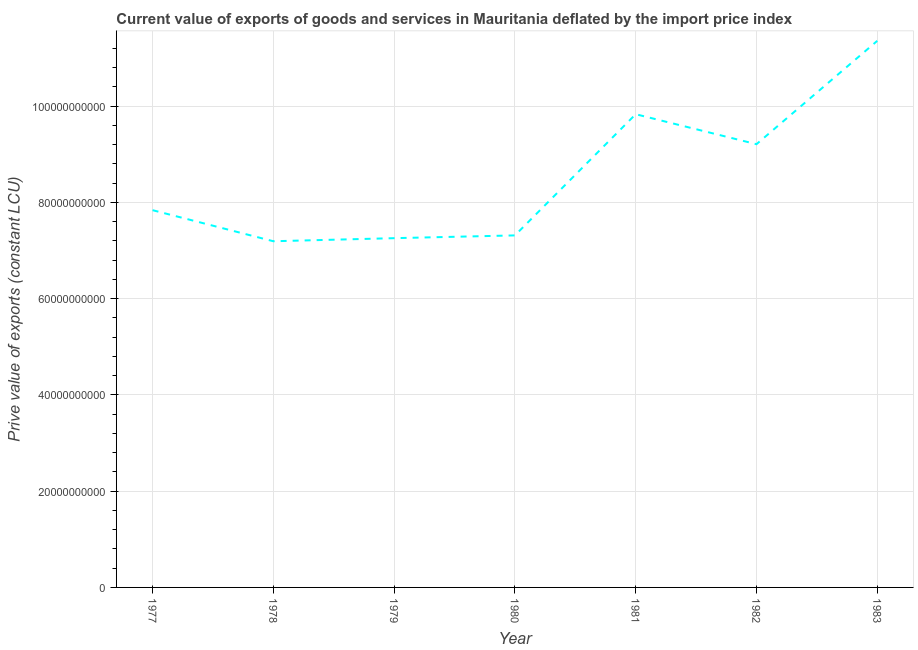What is the price value of exports in 1983?
Keep it short and to the point. 1.14e+11. Across all years, what is the maximum price value of exports?
Your answer should be very brief. 1.14e+11. Across all years, what is the minimum price value of exports?
Make the answer very short. 7.19e+1. In which year was the price value of exports minimum?
Make the answer very short. 1978. What is the sum of the price value of exports?
Give a very brief answer. 6.00e+11. What is the difference between the price value of exports in 1978 and 1980?
Provide a short and direct response. -1.21e+09. What is the average price value of exports per year?
Offer a terse response. 8.57e+1. What is the median price value of exports?
Make the answer very short. 7.84e+1. Do a majority of the years between 1982 and 1977 (inclusive) have price value of exports greater than 28000000000 LCU?
Offer a very short reply. Yes. What is the ratio of the price value of exports in 1978 to that in 1982?
Make the answer very short. 0.78. Is the price value of exports in 1977 less than that in 1981?
Offer a terse response. Yes. Is the difference between the price value of exports in 1981 and 1982 greater than the difference between any two years?
Your response must be concise. No. What is the difference between the highest and the second highest price value of exports?
Offer a terse response. 1.52e+1. What is the difference between the highest and the lowest price value of exports?
Keep it short and to the point. 4.16e+1. How many lines are there?
Your answer should be very brief. 1. How many years are there in the graph?
Your answer should be very brief. 7. Does the graph contain any zero values?
Make the answer very short. No. What is the title of the graph?
Your answer should be compact. Current value of exports of goods and services in Mauritania deflated by the import price index. What is the label or title of the Y-axis?
Ensure brevity in your answer.  Prive value of exports (constant LCU). What is the Prive value of exports (constant LCU) in 1977?
Ensure brevity in your answer.  7.84e+1. What is the Prive value of exports (constant LCU) of 1978?
Your response must be concise. 7.19e+1. What is the Prive value of exports (constant LCU) in 1979?
Ensure brevity in your answer.  7.26e+1. What is the Prive value of exports (constant LCU) in 1980?
Provide a short and direct response. 7.31e+1. What is the Prive value of exports (constant LCU) in 1981?
Your response must be concise. 9.83e+1. What is the Prive value of exports (constant LCU) of 1982?
Give a very brief answer. 9.21e+1. What is the Prive value of exports (constant LCU) in 1983?
Provide a short and direct response. 1.14e+11. What is the difference between the Prive value of exports (constant LCU) in 1977 and 1978?
Make the answer very short. 6.46e+09. What is the difference between the Prive value of exports (constant LCU) in 1977 and 1979?
Ensure brevity in your answer.  5.82e+09. What is the difference between the Prive value of exports (constant LCU) in 1977 and 1980?
Provide a short and direct response. 5.24e+09. What is the difference between the Prive value of exports (constant LCU) in 1977 and 1981?
Your answer should be very brief. -1.99e+1. What is the difference between the Prive value of exports (constant LCU) in 1977 and 1982?
Make the answer very short. -1.37e+1. What is the difference between the Prive value of exports (constant LCU) in 1977 and 1983?
Offer a terse response. -3.52e+1. What is the difference between the Prive value of exports (constant LCU) in 1978 and 1979?
Your answer should be compact. -6.39e+08. What is the difference between the Prive value of exports (constant LCU) in 1978 and 1980?
Your answer should be compact. -1.21e+09. What is the difference between the Prive value of exports (constant LCU) in 1978 and 1981?
Ensure brevity in your answer.  -2.64e+1. What is the difference between the Prive value of exports (constant LCU) in 1978 and 1982?
Provide a short and direct response. -2.02e+1. What is the difference between the Prive value of exports (constant LCU) in 1978 and 1983?
Your answer should be very brief. -4.16e+1. What is the difference between the Prive value of exports (constant LCU) in 1979 and 1980?
Make the answer very short. -5.75e+08. What is the difference between the Prive value of exports (constant LCU) in 1979 and 1981?
Ensure brevity in your answer.  -2.58e+1. What is the difference between the Prive value of exports (constant LCU) in 1979 and 1982?
Make the answer very short. -1.95e+1. What is the difference between the Prive value of exports (constant LCU) in 1979 and 1983?
Offer a terse response. -4.10e+1. What is the difference between the Prive value of exports (constant LCU) in 1980 and 1981?
Provide a succinct answer. -2.52e+1. What is the difference between the Prive value of exports (constant LCU) in 1980 and 1982?
Your answer should be compact. -1.89e+1. What is the difference between the Prive value of exports (constant LCU) in 1980 and 1983?
Keep it short and to the point. -4.04e+1. What is the difference between the Prive value of exports (constant LCU) in 1981 and 1982?
Your answer should be very brief. 6.23e+09. What is the difference between the Prive value of exports (constant LCU) in 1981 and 1983?
Offer a very short reply. -1.52e+1. What is the difference between the Prive value of exports (constant LCU) in 1982 and 1983?
Make the answer very short. -2.15e+1. What is the ratio of the Prive value of exports (constant LCU) in 1977 to that in 1978?
Your answer should be very brief. 1.09. What is the ratio of the Prive value of exports (constant LCU) in 1977 to that in 1980?
Your answer should be very brief. 1.07. What is the ratio of the Prive value of exports (constant LCU) in 1977 to that in 1981?
Your answer should be very brief. 0.8. What is the ratio of the Prive value of exports (constant LCU) in 1977 to that in 1982?
Make the answer very short. 0.85. What is the ratio of the Prive value of exports (constant LCU) in 1977 to that in 1983?
Give a very brief answer. 0.69. What is the ratio of the Prive value of exports (constant LCU) in 1978 to that in 1979?
Ensure brevity in your answer.  0.99. What is the ratio of the Prive value of exports (constant LCU) in 1978 to that in 1980?
Provide a succinct answer. 0.98. What is the ratio of the Prive value of exports (constant LCU) in 1978 to that in 1981?
Ensure brevity in your answer.  0.73. What is the ratio of the Prive value of exports (constant LCU) in 1978 to that in 1982?
Your answer should be very brief. 0.78. What is the ratio of the Prive value of exports (constant LCU) in 1978 to that in 1983?
Keep it short and to the point. 0.63. What is the ratio of the Prive value of exports (constant LCU) in 1979 to that in 1980?
Your answer should be very brief. 0.99. What is the ratio of the Prive value of exports (constant LCU) in 1979 to that in 1981?
Give a very brief answer. 0.74. What is the ratio of the Prive value of exports (constant LCU) in 1979 to that in 1982?
Keep it short and to the point. 0.79. What is the ratio of the Prive value of exports (constant LCU) in 1979 to that in 1983?
Ensure brevity in your answer.  0.64. What is the ratio of the Prive value of exports (constant LCU) in 1980 to that in 1981?
Your response must be concise. 0.74. What is the ratio of the Prive value of exports (constant LCU) in 1980 to that in 1982?
Provide a succinct answer. 0.79. What is the ratio of the Prive value of exports (constant LCU) in 1980 to that in 1983?
Make the answer very short. 0.64. What is the ratio of the Prive value of exports (constant LCU) in 1981 to that in 1982?
Make the answer very short. 1.07. What is the ratio of the Prive value of exports (constant LCU) in 1981 to that in 1983?
Ensure brevity in your answer.  0.87. What is the ratio of the Prive value of exports (constant LCU) in 1982 to that in 1983?
Offer a very short reply. 0.81. 